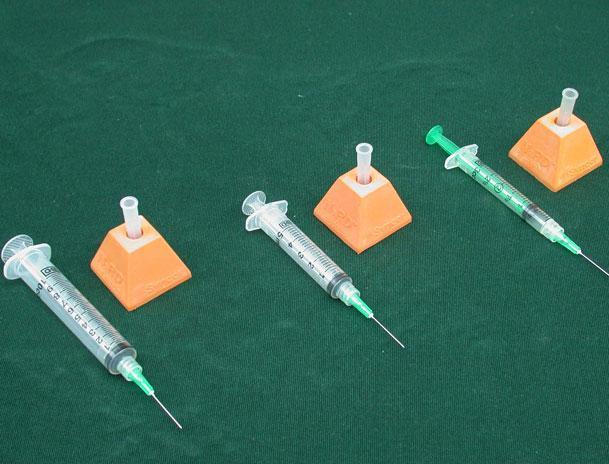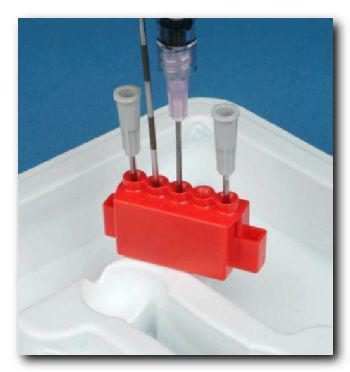The first image is the image on the left, the second image is the image on the right. For the images displayed, is the sentence "A person is inserting a syringe into an orange holder." factually correct? Answer yes or no. No. 